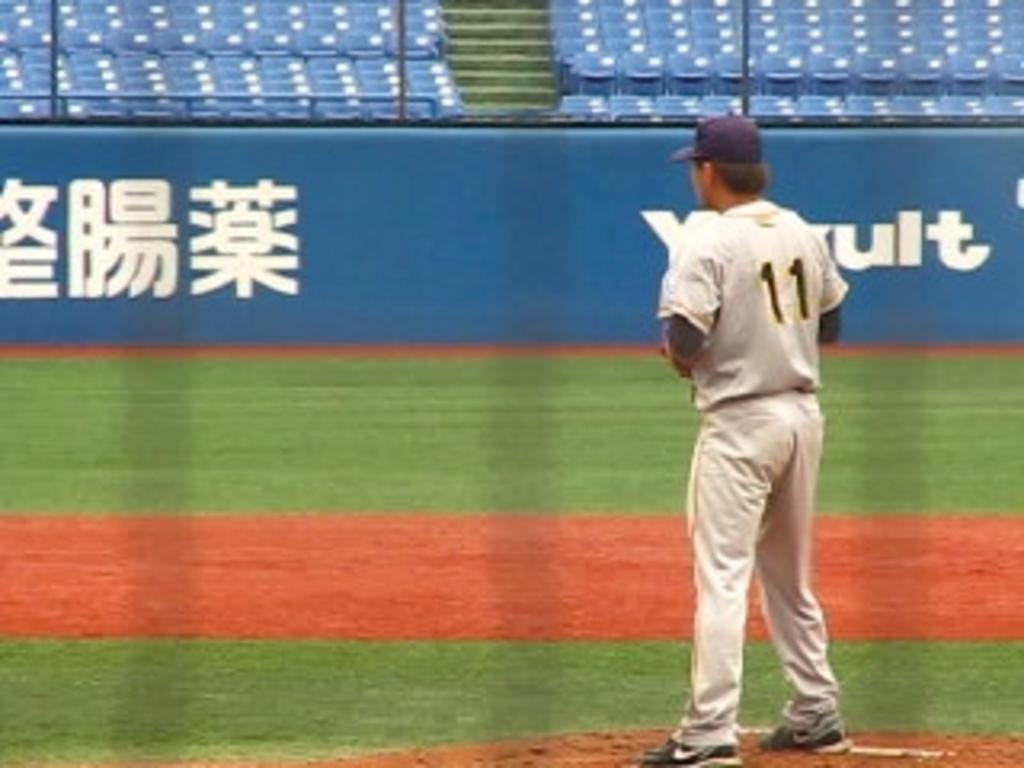<image>
Provide a brief description of the given image. A baseball player with the number 11 on his back 